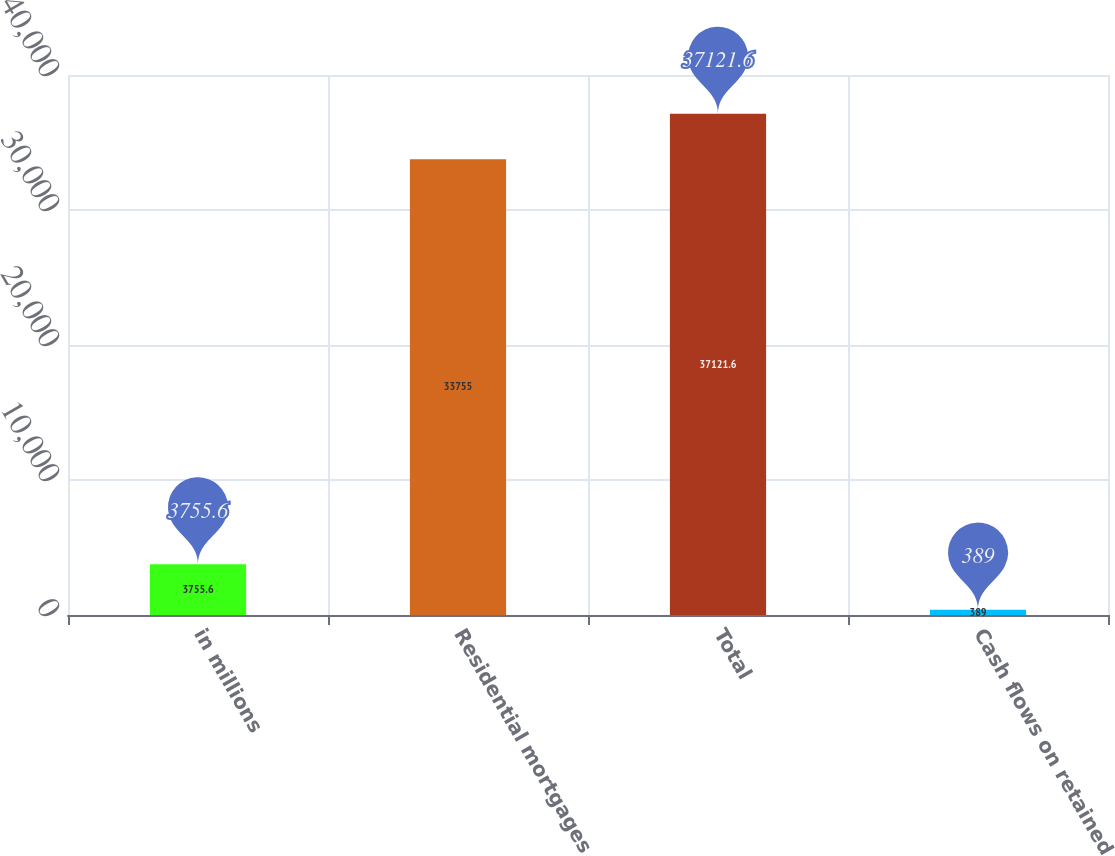Convert chart to OTSL. <chart><loc_0><loc_0><loc_500><loc_500><bar_chart><fcel>in millions<fcel>Residential mortgages<fcel>Total<fcel>Cash flows on retained<nl><fcel>3755.6<fcel>33755<fcel>37121.6<fcel>389<nl></chart> 